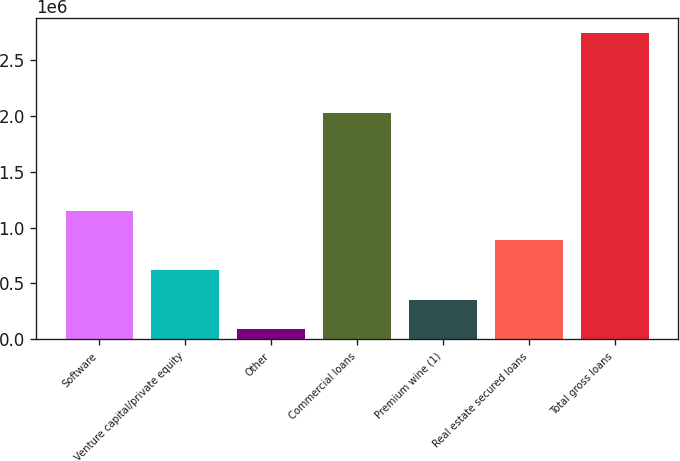<chart> <loc_0><loc_0><loc_500><loc_500><bar_chart><fcel>Software<fcel>Venture capital/private equity<fcel>Other<fcel>Commercial loans<fcel>Premium wine (1)<fcel>Real estate secured loans<fcel>Total gross loans<nl><fcel>1.14902e+06<fcel>619363<fcel>89703<fcel>2.02657e+06<fcel>354533<fcel>884193<fcel>2.738e+06<nl></chart> 